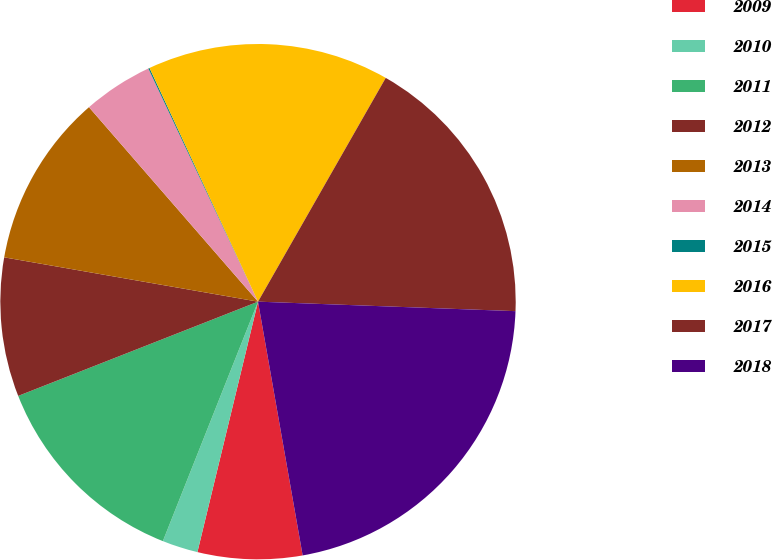Convert chart. <chart><loc_0><loc_0><loc_500><loc_500><pie_chart><fcel>2009<fcel>2010<fcel>2011<fcel>2012<fcel>2013<fcel>2014<fcel>2015<fcel>2016<fcel>2017<fcel>2018<nl><fcel>6.55%<fcel>2.24%<fcel>13.02%<fcel>8.71%<fcel>10.86%<fcel>4.39%<fcel>0.08%<fcel>15.17%<fcel>17.33%<fcel>21.64%<nl></chart> 